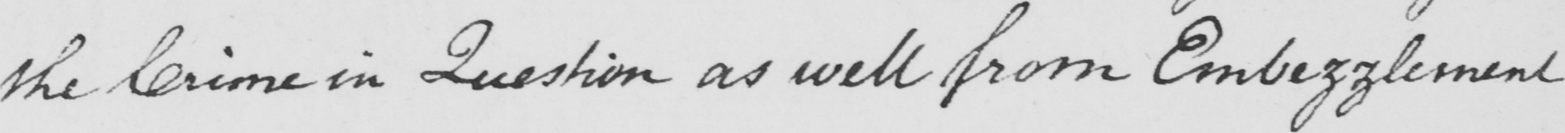Transcribe the text shown in this historical manuscript line. the Crime in Question as well from Embezzlement 